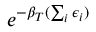<formula> <loc_0><loc_0><loc_500><loc_500>e ^ { - \beta _ { T } ( \sum _ { i } \epsilon _ { i } ) }</formula> 